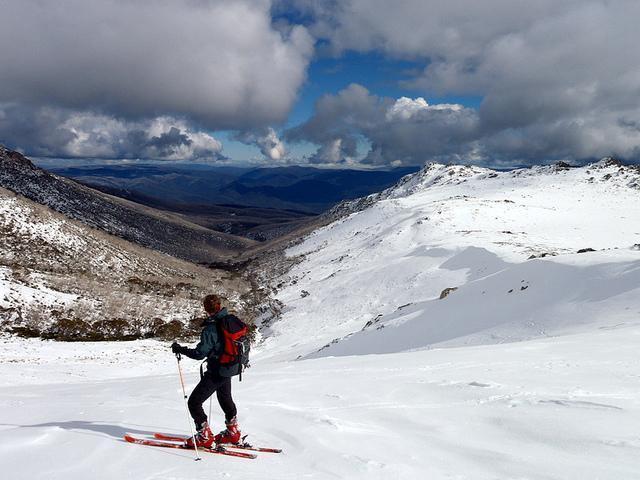How many chairs are on the right side of the tree?
Give a very brief answer. 0. 